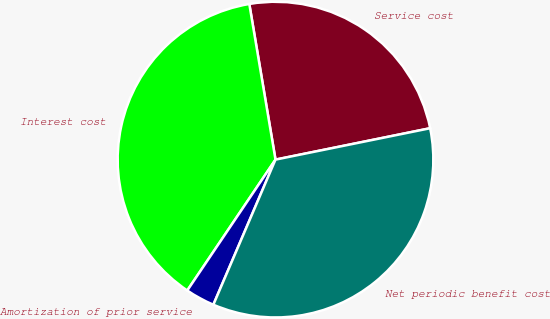Convert chart to OTSL. <chart><loc_0><loc_0><loc_500><loc_500><pie_chart><fcel>Service cost<fcel>Interest cost<fcel>Amortization of prior service<fcel>Net periodic benefit cost<nl><fcel>24.47%<fcel>37.91%<fcel>3.0%<fcel>34.63%<nl></chart> 